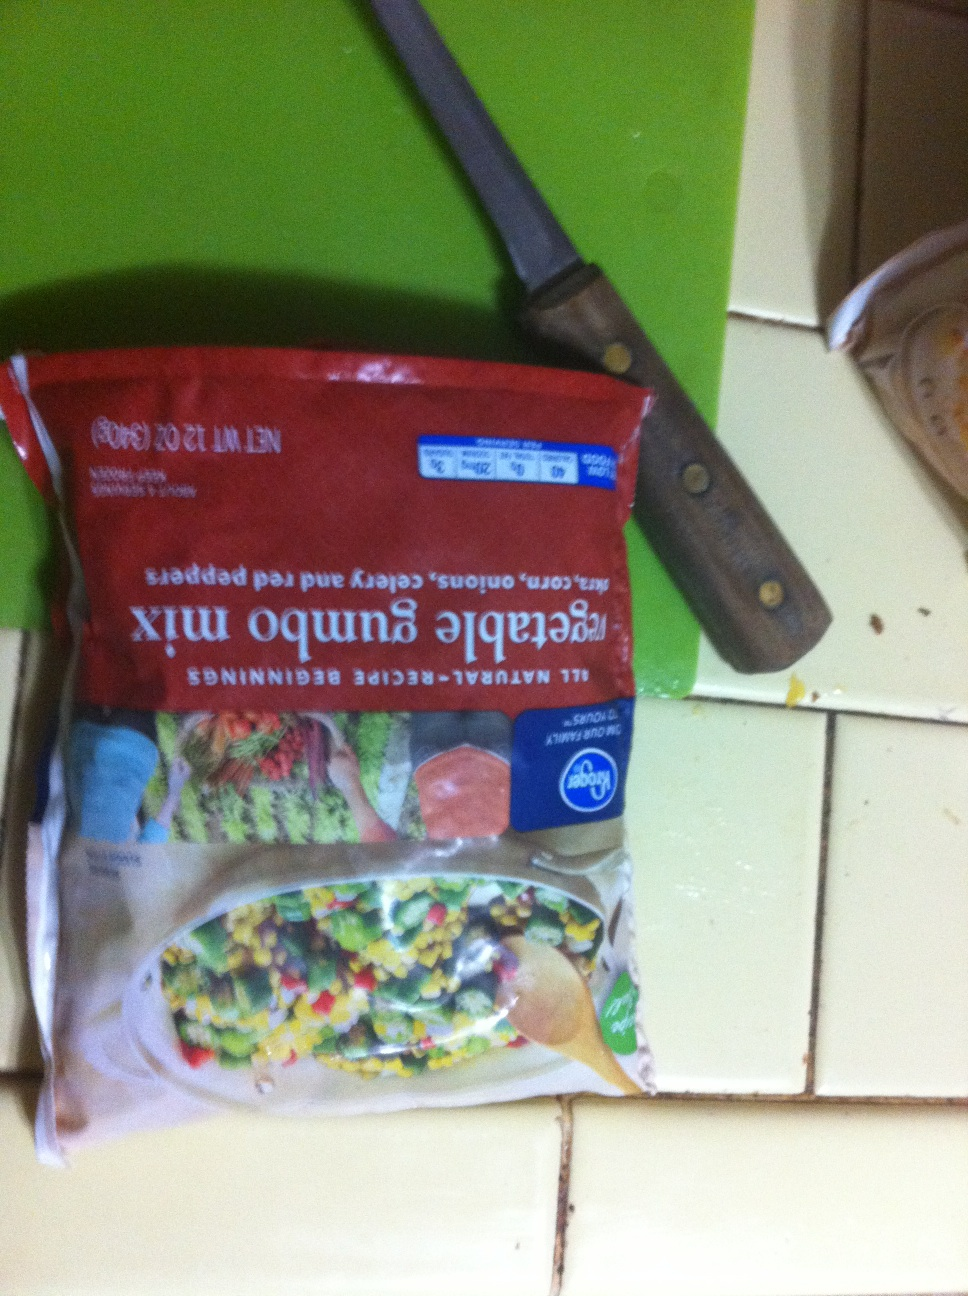Describe the best way to store this vegetable gumbo mix. To ensure the freshness of your vegetable gumbo mix, store it in the freezer. Make sure the package is sealed properly to prevent freezer burn. If you open the packet and don't use all the contents, transfer the remaining vegetables to an airtight container or resealable plastic bag before returning it to the freezer. Can I use this mix for anything other than gumbo? Absolutely! This vegetable mix is versatile and can be used in a variety of dishes. You can add it to soups, stews, stir-fries, or even scrambled eggs for a hearty breakfast. It also works well as a side dish when sautéed with a bit of seasoning. Get creative and experiment with different recipes to make the most out of this vegetable mix. 